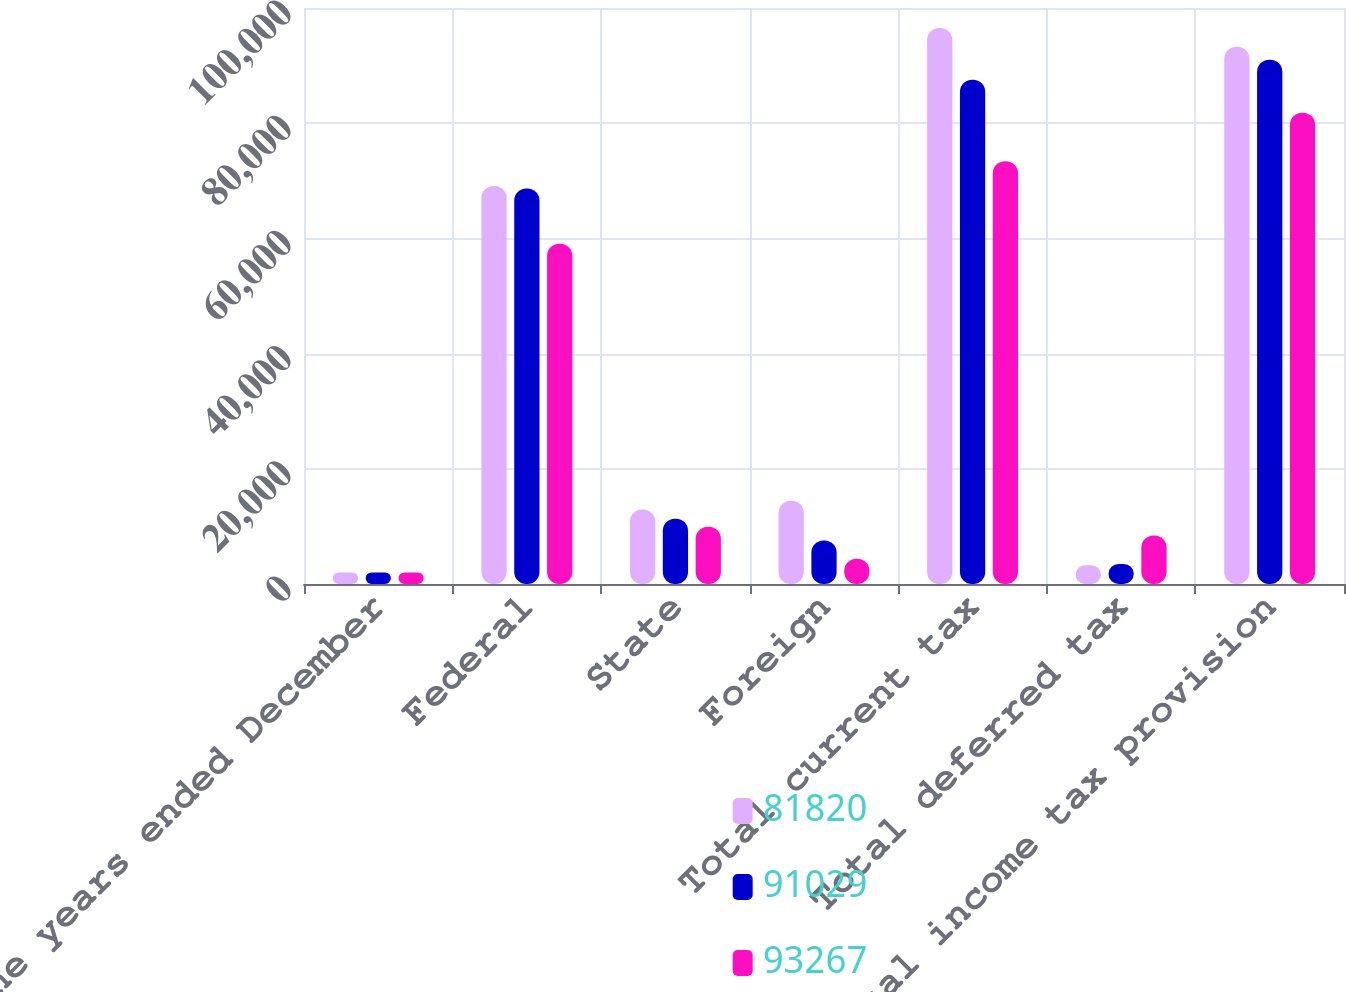Convert chart to OTSL. <chart><loc_0><loc_0><loc_500><loc_500><stacked_bar_chart><ecel><fcel>For the years ended December<fcel>Federal<fcel>State<fcel>Foreign<fcel>Total current tax<fcel>Total deferred tax<fcel>Total income tax provision<nl><fcel>81820<fcel>2016<fcel>69102<fcel>12949<fcel>14464<fcel>96515<fcel>3248<fcel>93267<nl><fcel>91029<fcel>2015<fcel>68667<fcel>11335<fcel>7534<fcel>87536<fcel>3493<fcel>91029<nl><fcel>93267<fcel>2014<fcel>59053<fcel>9936<fcel>4391<fcel>73380<fcel>8440<fcel>81820<nl></chart> 